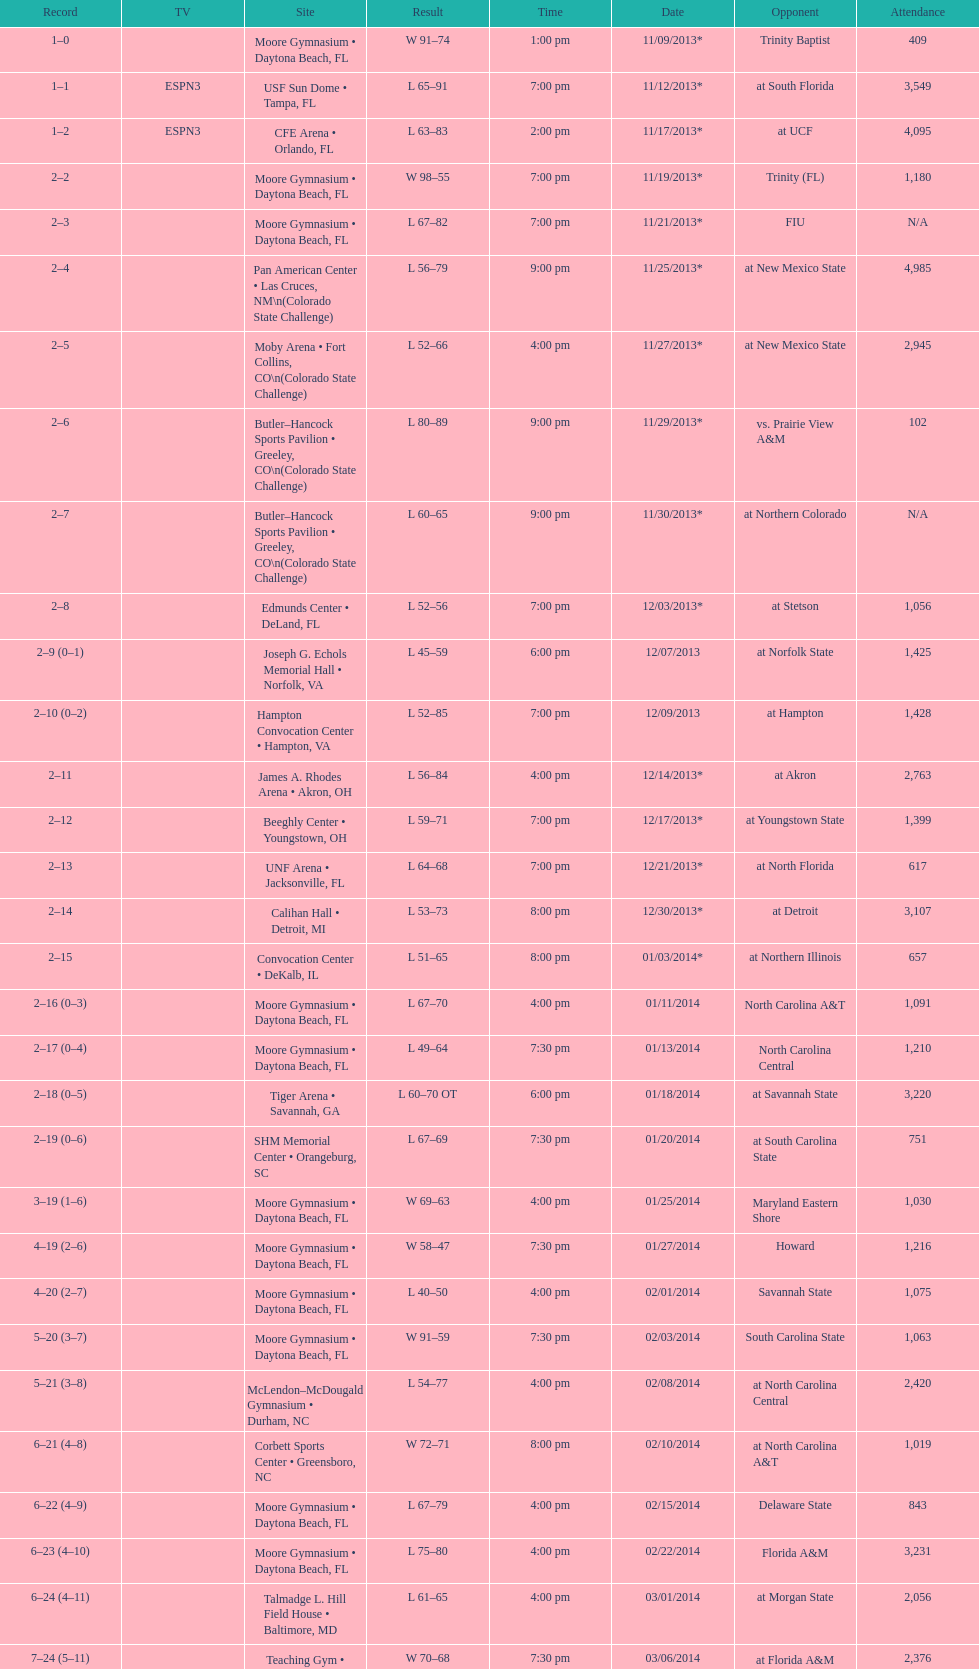How many games had more than 1,500 in attendance? 12. 